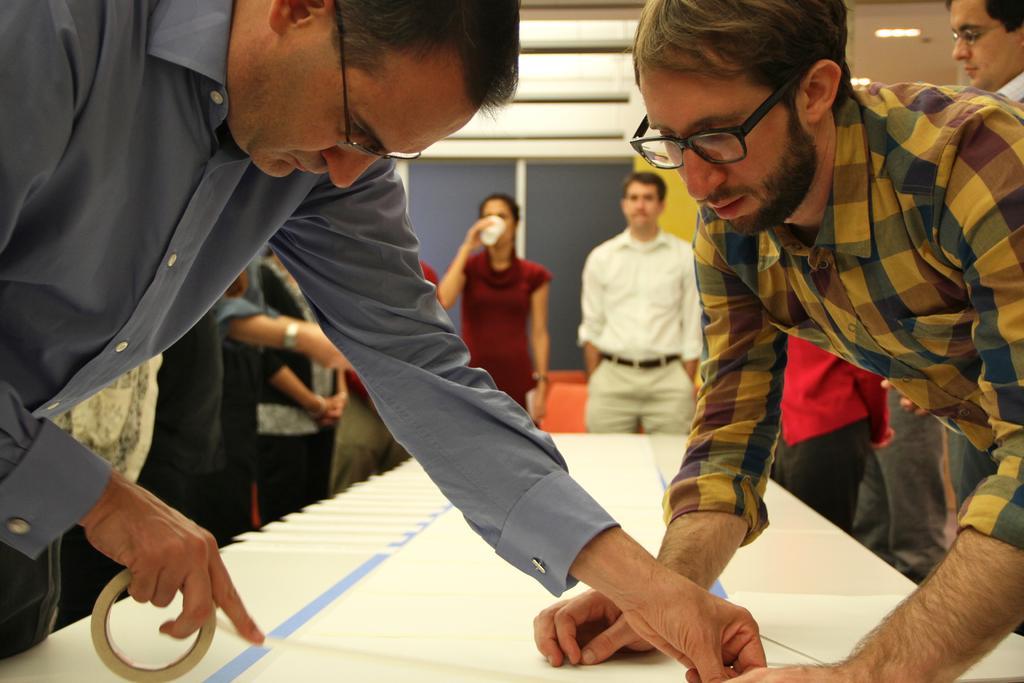How would you summarize this image in a sentence or two? In this picture there are two men who are standing near to the table and they are holding the plaster. In the back I can see many people who are standing near to the table and chairs. In the background I can see the window. In the top left I can see the lights on the roof. 